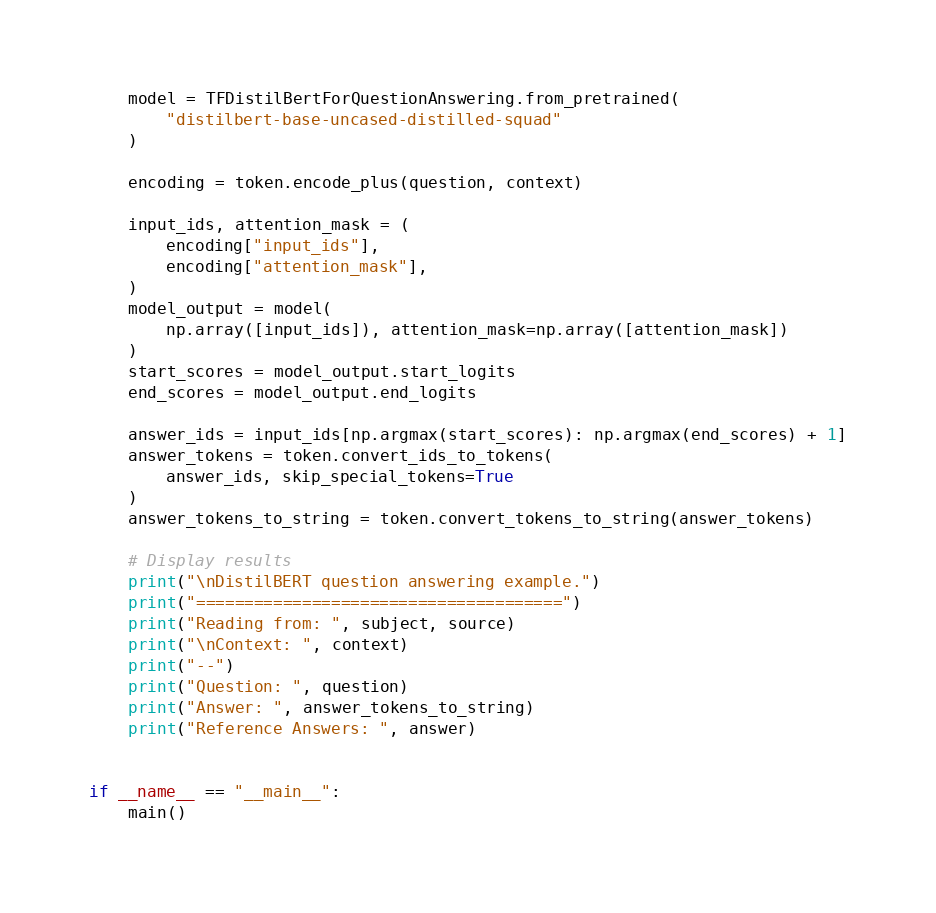<code> <loc_0><loc_0><loc_500><loc_500><_Python_>    model = TFDistilBertForQuestionAnswering.from_pretrained(
        "distilbert-base-uncased-distilled-squad"
    )

    encoding = token.encode_plus(question, context)

    input_ids, attention_mask = (
        encoding["input_ids"],
        encoding["attention_mask"],
    )
    model_output = model(
        np.array([input_ids]), attention_mask=np.array([attention_mask])
    )
    start_scores = model_output.start_logits
    end_scores = model_output.end_logits

    answer_ids = input_ids[np.argmax(start_scores): np.argmax(end_scores) + 1]
    answer_tokens = token.convert_ids_to_tokens(
        answer_ids, skip_special_tokens=True
    )
    answer_tokens_to_string = token.convert_tokens_to_string(answer_tokens)

    # Display results
    print("\nDistilBERT question answering example.")
    print("======================================")
    print("Reading from: ", subject, source)
    print("\nContext: ", context)
    print("--")
    print("Question: ", question)
    print("Answer: ", answer_tokens_to_string)
    print("Reference Answers: ", answer)


if __name__ == "__main__":
    main()
</code> 